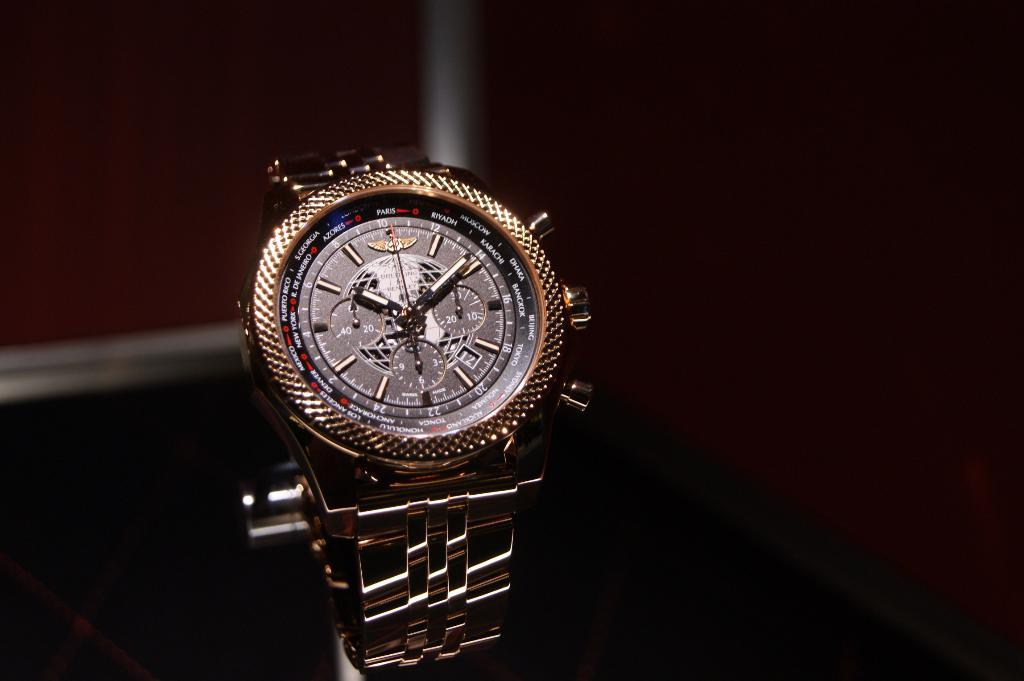<image>
Summarize the visual content of the image. A watch has the number 12 in the little date window near the number 4. 